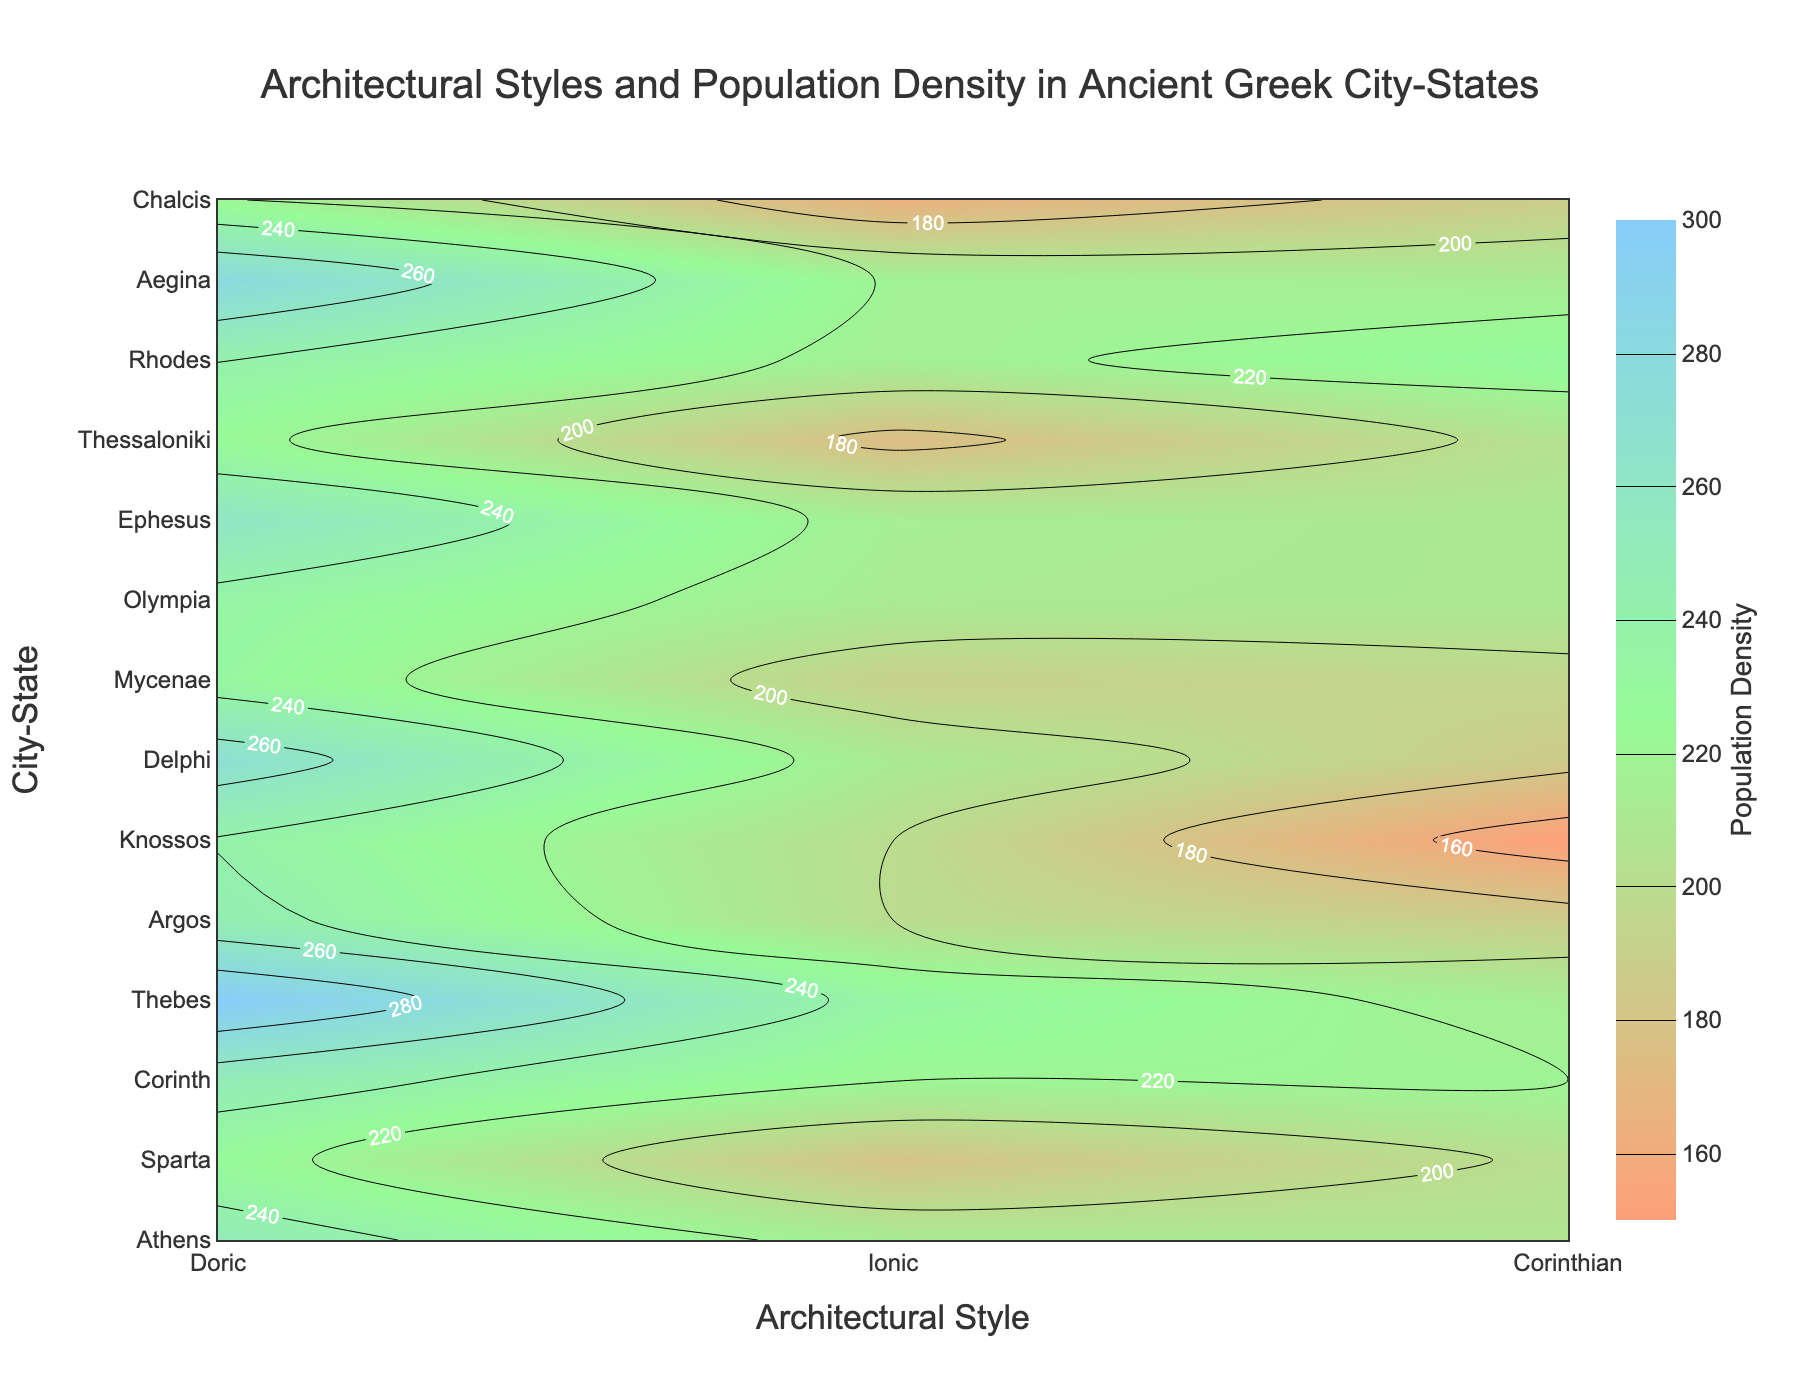What is the population density of Athens according to the figure? To answer this question, locate "Athens" on the vertical axis (City-State) and find its corresponding population density value on the contour plot.
Answer: 250 Which architectural style is associated with the highest population density in the figure? Identify the architectural style on the horizontal axis linked to the highest population density value on the contour plot.
Answer: Doric What is the highest recorded population density across all City-States? Look at the color bar and the contour plot to identify the highest population density value represented.
Answer: 300 How does the population density of Corinth (220) compare to that of Delphi (270)? Locate Corinth and Delphi on the vertical axis and compare their corresponding population density values on the contour plot to determine which is higher.
Answer: Delphi is higher Among Doric, Ionic, and Corinthian styles, which architectural style has the most City-States with a population density above 250? Count the City-States associated with each architectural style that have population densities greater than 250 on the contour plot.
Answer: Doric What range of population densities does the city-state of Sparta fall within? Locate Sparta on the vertical axis and observe the contour lines and color shading to identify the range of population densities.
Answer: 180-200 Which City-State associated with the Corinthian architectural style has the lowest population density? Locate the City-States associated with Corinthian style on the vertical axis and identify the one with the lowest population density according to the contour lines.
Answer: Knossos Calculate the average population density for City-States with the Ionic architectural style. Identify the population densities for all City-States with the Ionic style, sum them, and divide by the number of Ionic City-States.
Answer: Average is (180+200+190+175+165)/5 = 182 What is the title of the figure? The title is typically placed at the top of the figure. Locate and read the title text.
Answer: Architectural Styles and Population Density in Ancient Greek City-States 